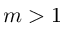<formula> <loc_0><loc_0><loc_500><loc_500>m > 1</formula> 